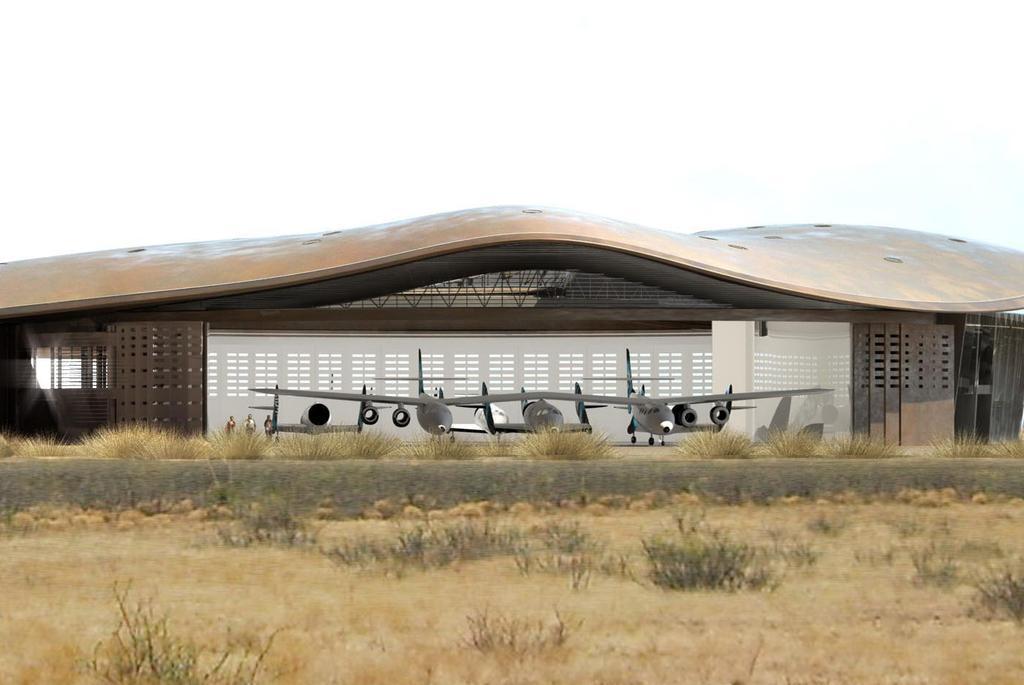Could you give a brief overview of what you see in this image? In this image we can see a building, in front of the building we can see some airplanes, people, grass, plants and stones. In the background, we can see the sky. 